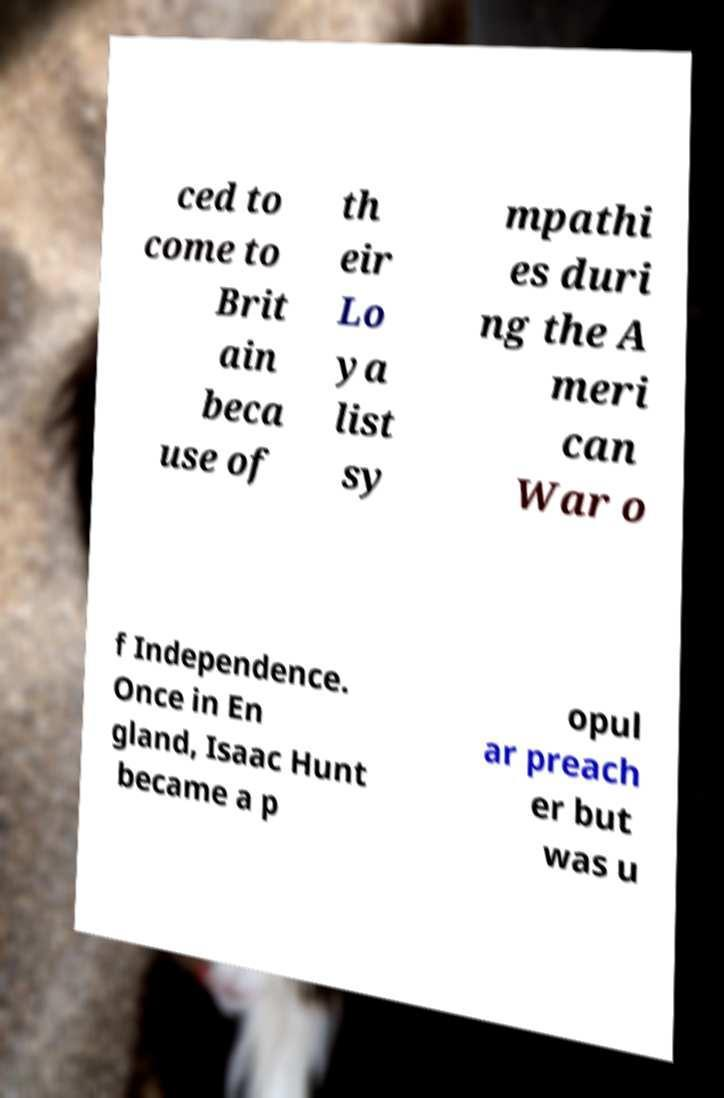For documentation purposes, I need the text within this image transcribed. Could you provide that? ced to come to Brit ain beca use of th eir Lo ya list sy mpathi es duri ng the A meri can War o f Independence. Once in En gland, Isaac Hunt became a p opul ar preach er but was u 